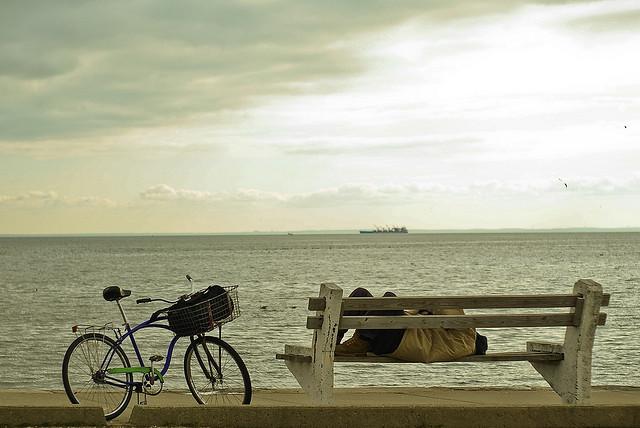What color is her purse?
Short answer required. Black. Is there a boat in the water?
Concise answer only. Yes. Is it raining in this picture?
Write a very short answer. No. What is in the basket on the bicycle?
Concise answer only. Bag. What is on the horizon?
Write a very short answer. Ship. What does a helmet do?
Short answer required. Protect head. Is there a shadow in the image?
Be succinct. No. What is on the back of the bike?
Quick response, please. Rack. Is there someone at the bench?
Give a very brief answer. Yes. 